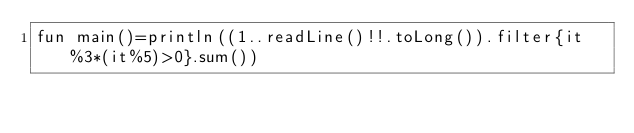<code> <loc_0><loc_0><loc_500><loc_500><_Kotlin_>fun main()=println((1..readLine()!!.toLong()).filter{it%3*(it%5)>0}.sum())</code> 